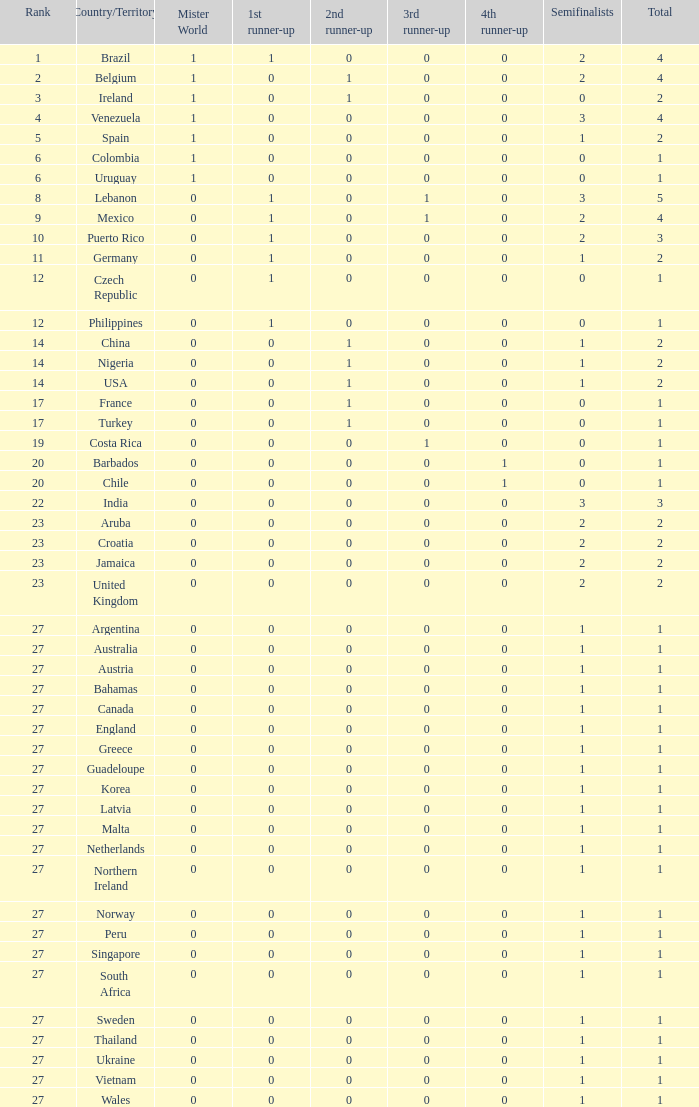What is the smallest value for the first runner up? 0.0. 